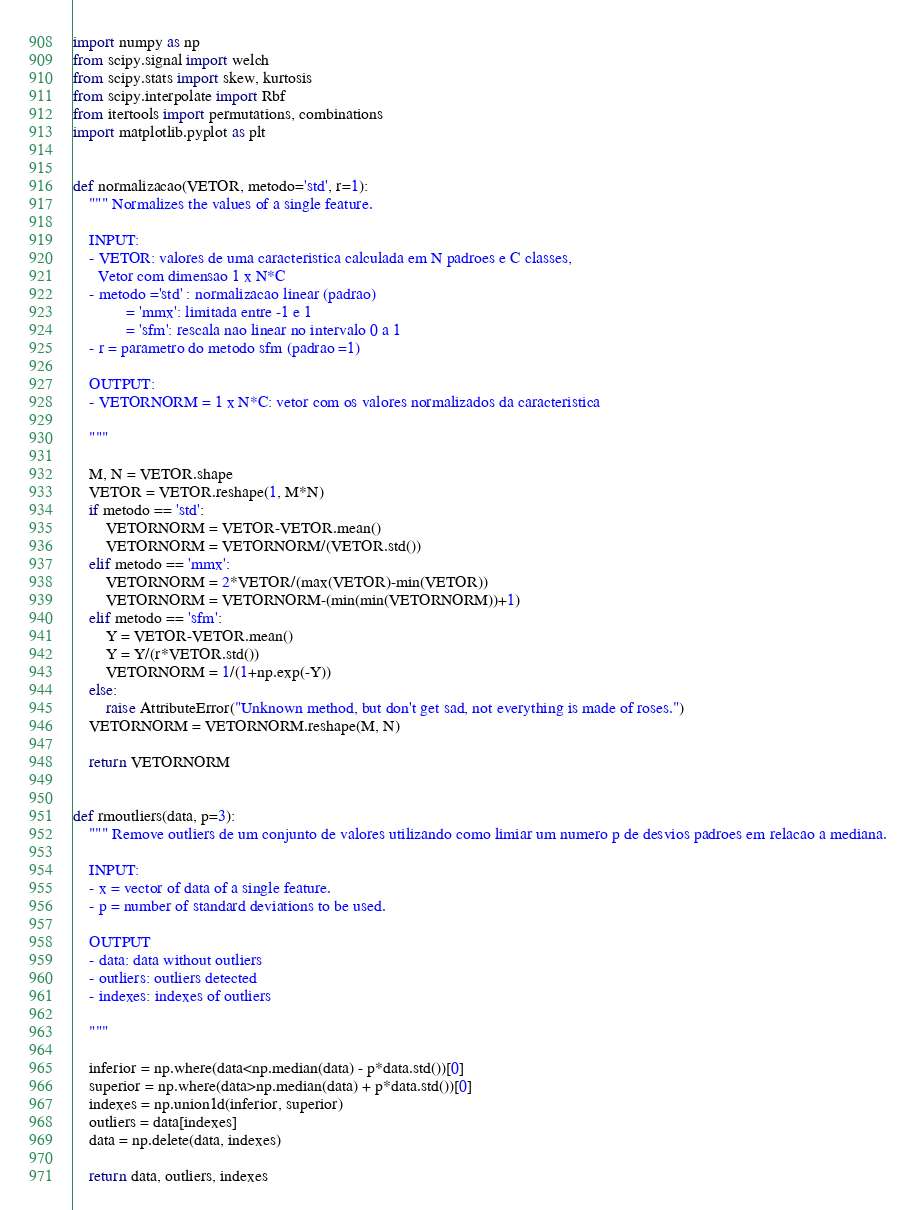<code> <loc_0><loc_0><loc_500><loc_500><_Python_>import numpy as np
from scipy.signal import welch
from scipy.stats import skew, kurtosis
from scipy.interpolate import Rbf
from itertools import permutations, combinations
import matplotlib.pyplot as plt 


def normalizacao(VETOR, metodo='std', r=1):
	""" Normalizes the values of a single feature.

	INPUT:
	- VETOR: valores de uma caracteristica calculada em N padroes e C classes,
	  Vetor com dimensao 1 x N*C
	- metodo ='std' : normalizacao linear (padrao)
	         = 'mmx': limitada entre -1 e 1
	         = 'sfm': rescala nao linear no intervalo 0 a 1
	- r = parametro do metodo sfm (padrao =1)
	
	OUTPUT:
	- VETORNORM = 1 x N*C: vetor com os valores normalizados da caracteristica 
	
	"""
	
	M, N = VETOR.shape
	VETOR = VETOR.reshape(1, M*N)
	if metodo == 'std':
		VETORNORM = VETOR-VETOR.mean()
		VETORNORM = VETORNORM/(VETOR.std())
	elif metodo == 'mmx':
		VETORNORM = 2*VETOR/(max(VETOR)-min(VETOR))
		VETORNORM = VETORNORM-(min(min(VETORNORM))+1)
	elif metodo == 'sfm':
		Y = VETOR-VETOR.mean()
		Y = Y/(r*VETOR.std())
		VETORNORM = 1/(1+np.exp(-Y))
	else:
		raise AttributeError("Unknown method, but don't get sad, not everything is made of roses.")
	VETORNORM = VETORNORM.reshape(M, N)

	return VETORNORM


def rmoutliers(data, p=3):
	""" Remove outliers de um conjunto de valores utilizando como limiar um numero p de desvios padroes em relacao a mediana.

	INPUT:
	- x = vector of data of a single feature.
	- p = number of standard deviations to be used.
	
	OUTPUT
	- data: data without outliers
	- outliers: outliers detected
	- indexes: indexes of outliers

	"""

	inferior = np.where(data<np.median(data) - p*data.std())[0]
	superior = np.where(data>np.median(data) + p*data.std())[0]
	indexes = np.union1d(inferior, superior)
	outliers = data[indexes]
	data = np.delete(data, indexes)

	return data, outliers, indexes


</code> 